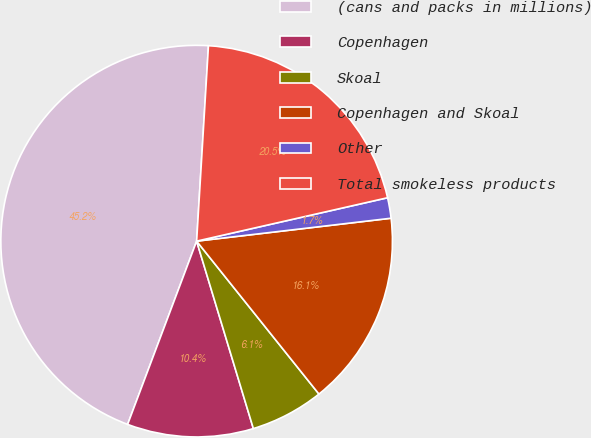Convert chart to OTSL. <chart><loc_0><loc_0><loc_500><loc_500><pie_chart><fcel>(cans and packs in millions)<fcel>Copenhagen<fcel>Skoal<fcel>Copenhagen and Skoal<fcel>Other<fcel>Total smokeless products<nl><fcel>45.23%<fcel>10.41%<fcel>6.06%<fcel>16.13%<fcel>1.69%<fcel>20.48%<nl></chart> 